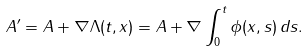<formula> <loc_0><loc_0><loc_500><loc_500>A ^ { \prime } = A + \nabla \Lambda ( t , x ) = A + \nabla \int ^ { t } _ { 0 } \phi ( x , s ) \, d s .</formula> 